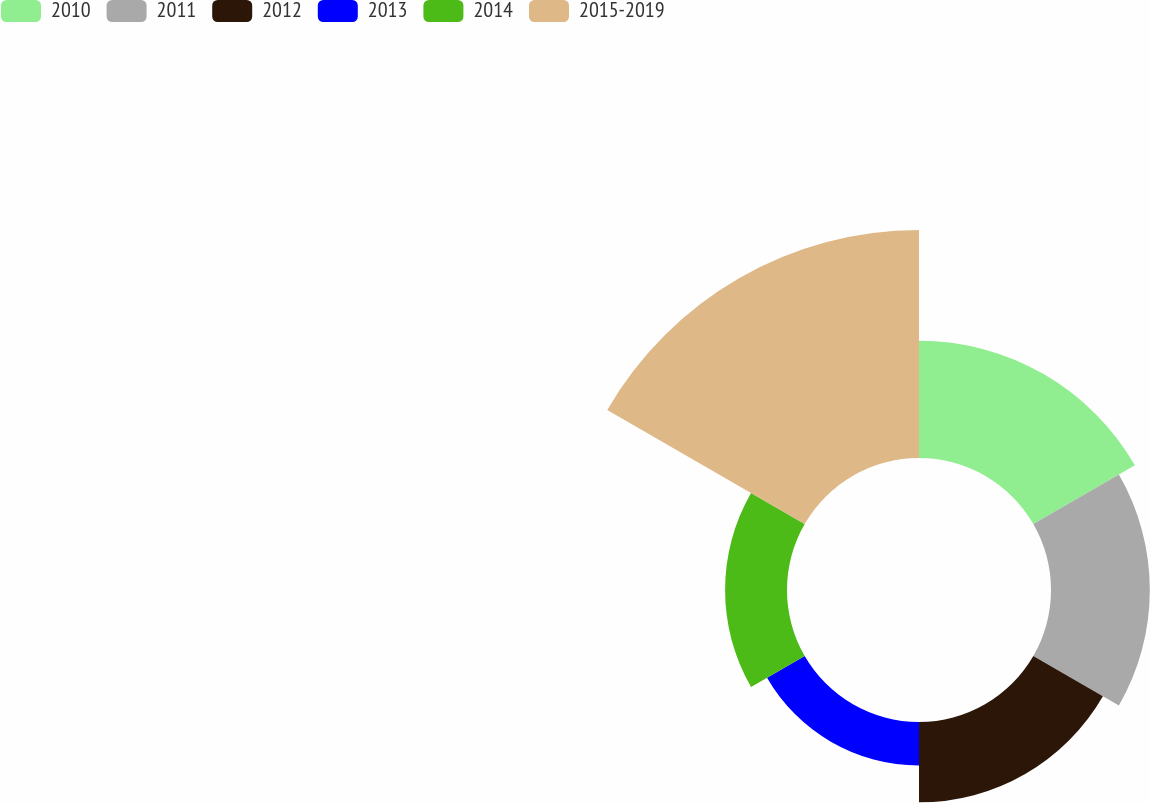Convert chart. <chart><loc_0><loc_0><loc_500><loc_500><pie_chart><fcel>2010<fcel>2011<fcel>2012<fcel>2013<fcel>2014<fcel>2015-2019<nl><fcel>18.62%<fcel>15.69%<fcel>12.76%<fcel>6.9%<fcel>9.83%<fcel>36.2%<nl></chart> 